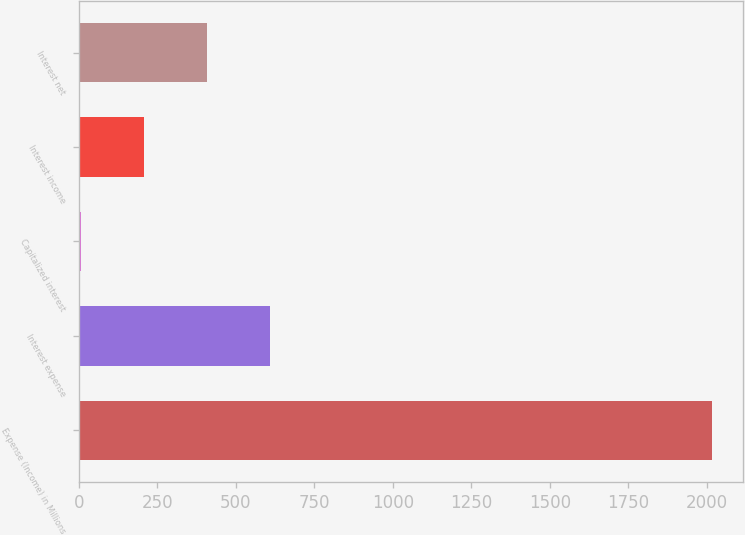Convert chart. <chart><loc_0><loc_0><loc_500><loc_500><bar_chart><fcel>Expense (Income) in Millions<fcel>Interest expense<fcel>Capitalized interest<fcel>Interest income<fcel>Interest net<nl><fcel>2016<fcel>610.19<fcel>7.7<fcel>208.53<fcel>409.36<nl></chart> 